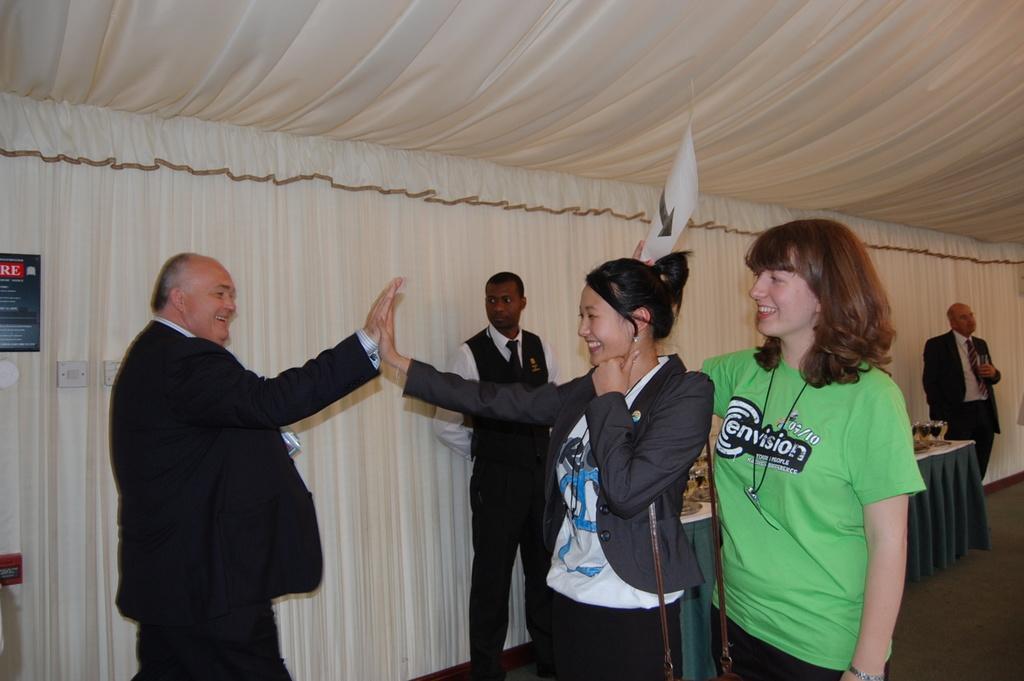Can you describe this image briefly? In the center of the image we can see many persons standing on the ground. In the background we can see curtains, tables, glass tumblers, beverages and persons. 